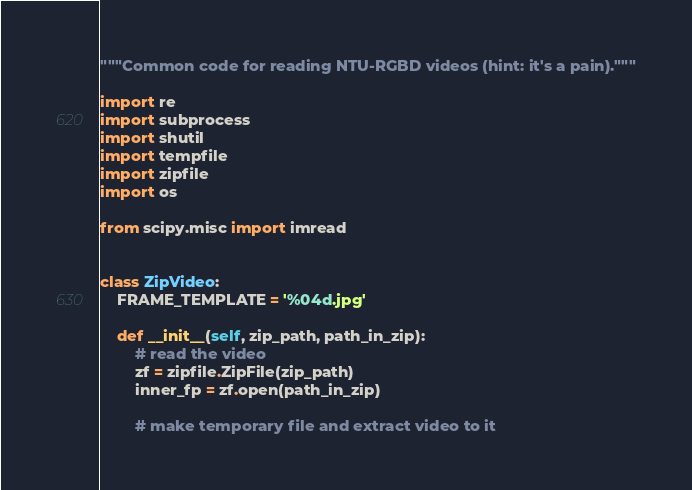<code> <loc_0><loc_0><loc_500><loc_500><_Python_>"""Common code for reading NTU-RGBD videos (hint: it's a pain)."""

import re
import subprocess
import shutil
import tempfile
import zipfile
import os

from scipy.misc import imread


class ZipVideo:
    FRAME_TEMPLATE = '%04d.jpg'

    def __init__(self, zip_path, path_in_zip):
        # read the video
        zf = zipfile.ZipFile(zip_path)
        inner_fp = zf.open(path_in_zip)

        # make temporary file and extract video to it</code> 